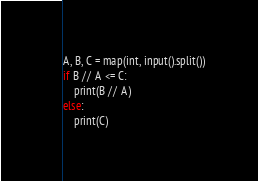Convert code to text. <code><loc_0><loc_0><loc_500><loc_500><_Python_>A, B, C = map(int, input().split())
if B // A <= C:
	print(B // A)
else:
	print(C)
</code> 